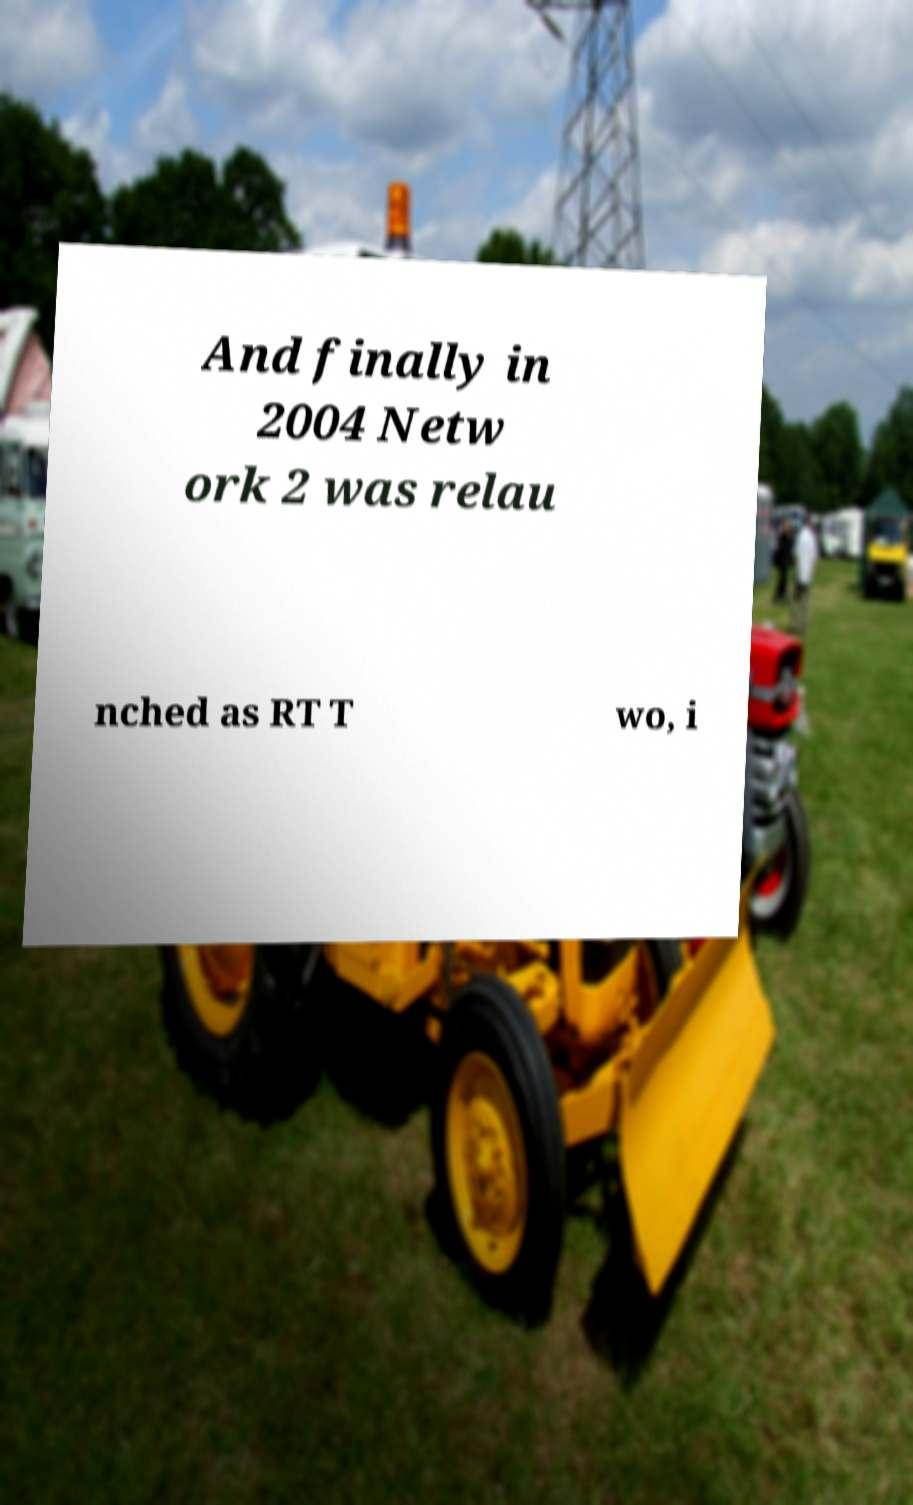There's text embedded in this image that I need extracted. Can you transcribe it verbatim? And finally in 2004 Netw ork 2 was relau nched as RT T wo, i 